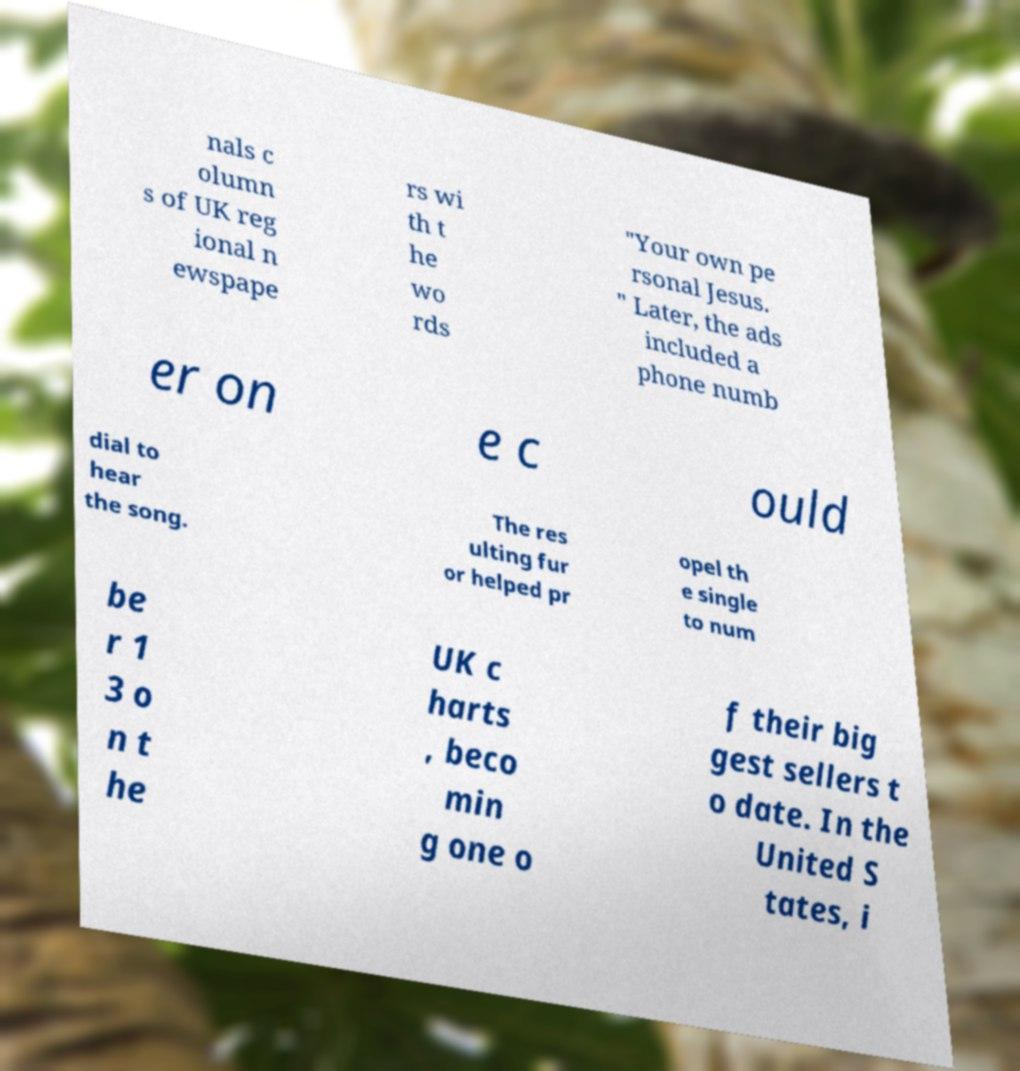Could you extract and type out the text from this image? nals c olumn s of UK reg ional n ewspape rs wi th t he wo rds "Your own pe rsonal Jesus. " Later, the ads included a phone numb er on e c ould dial to hear the song. The res ulting fur or helped pr opel th e single to num be r 1 3 o n t he UK c harts , beco min g one o f their big gest sellers t o date. In the United S tates, i 